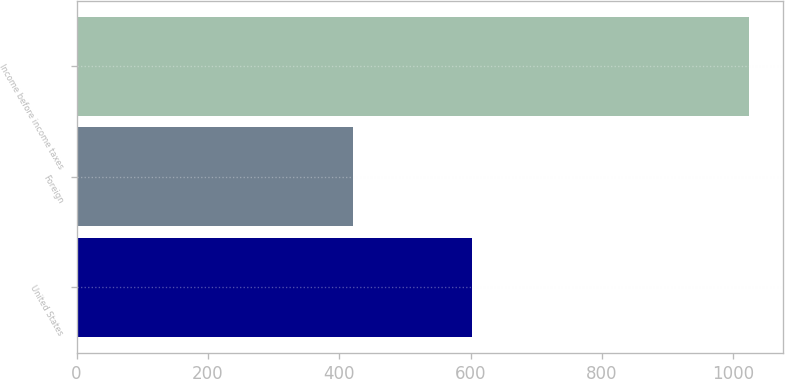<chart> <loc_0><loc_0><loc_500><loc_500><bar_chart><fcel>United States<fcel>Foreign<fcel>Income before income taxes<nl><fcel>602.1<fcel>421.5<fcel>1023.6<nl></chart> 